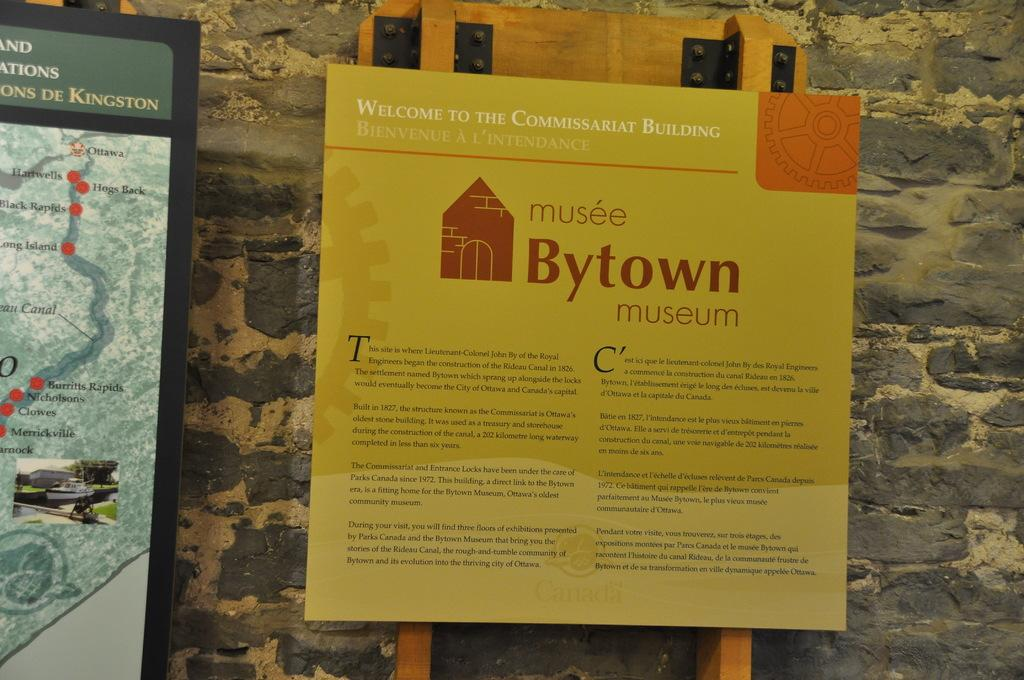<image>
Summarize the visual content of the image. A sign providing information and welcoming people to the Commissariat Building of the Bytown museum. 